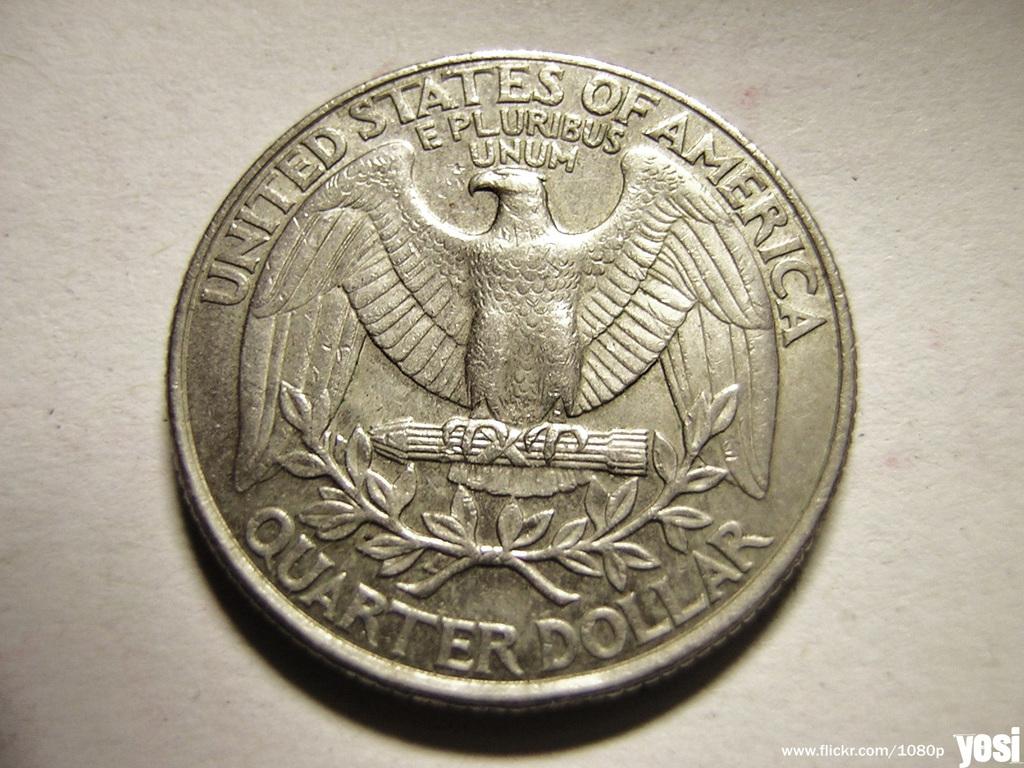How much is this coin?
Keep it short and to the point. Quarter dollar. What country is the coin from?
Your response must be concise. United states of america. 